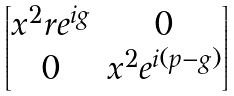<formula> <loc_0><loc_0><loc_500><loc_500>\begin{bmatrix} x ^ { 2 } r e ^ { i g } & 0 \\ 0 & x ^ { 2 } e ^ { i ( p - g ) } \end{bmatrix}</formula> 